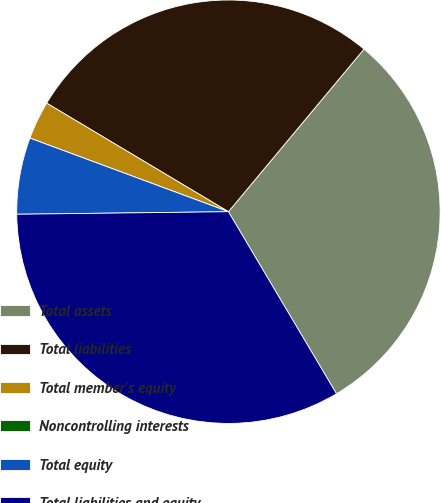Convert chart. <chart><loc_0><loc_0><loc_500><loc_500><pie_chart><fcel>Total assets<fcel>Total liabilities<fcel>Total member's equity<fcel>Noncontrolling interests<fcel>Total equity<fcel>Total liabilities and equity<nl><fcel>30.41%<fcel>27.49%<fcel>2.92%<fcel>0.0%<fcel>5.84%<fcel>33.33%<nl></chart> 